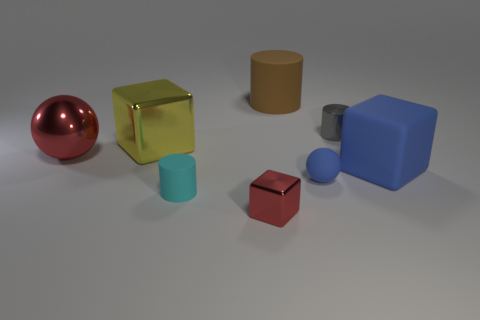Subtract all gray spheres. Subtract all gray blocks. How many spheres are left? 2 Add 1 big yellow matte balls. How many objects exist? 9 Subtract all cylinders. How many objects are left? 5 Subtract all big brown metallic objects. Subtract all tiny cylinders. How many objects are left? 6 Add 5 matte cubes. How many matte cubes are left? 6 Add 8 small gray cubes. How many small gray cubes exist? 8 Subtract 1 blue spheres. How many objects are left? 7 